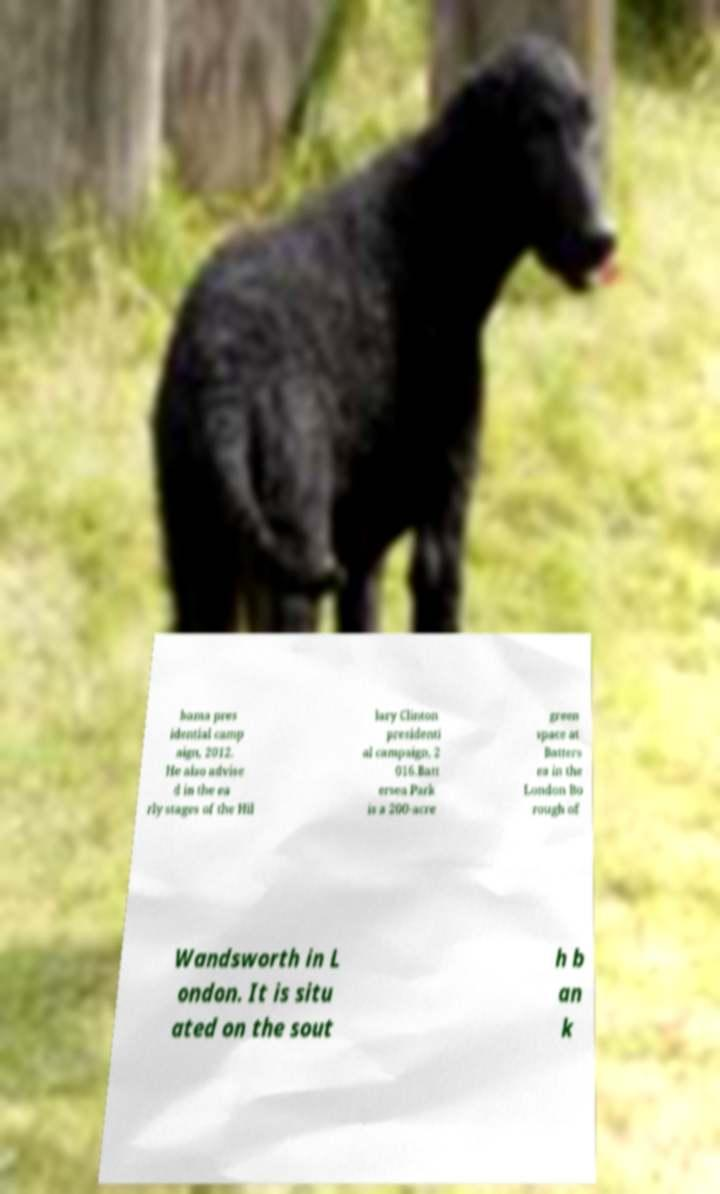Can you read and provide the text displayed in the image?This photo seems to have some interesting text. Can you extract and type it out for me? bama pres idential camp aign, 2012. He also advise d in the ea rly stages of the Hil lary Clinton presidenti al campaign, 2 016.Batt ersea Park is a 200-acre green space at Batters ea in the London Bo rough of Wandsworth in L ondon. It is situ ated on the sout h b an k 